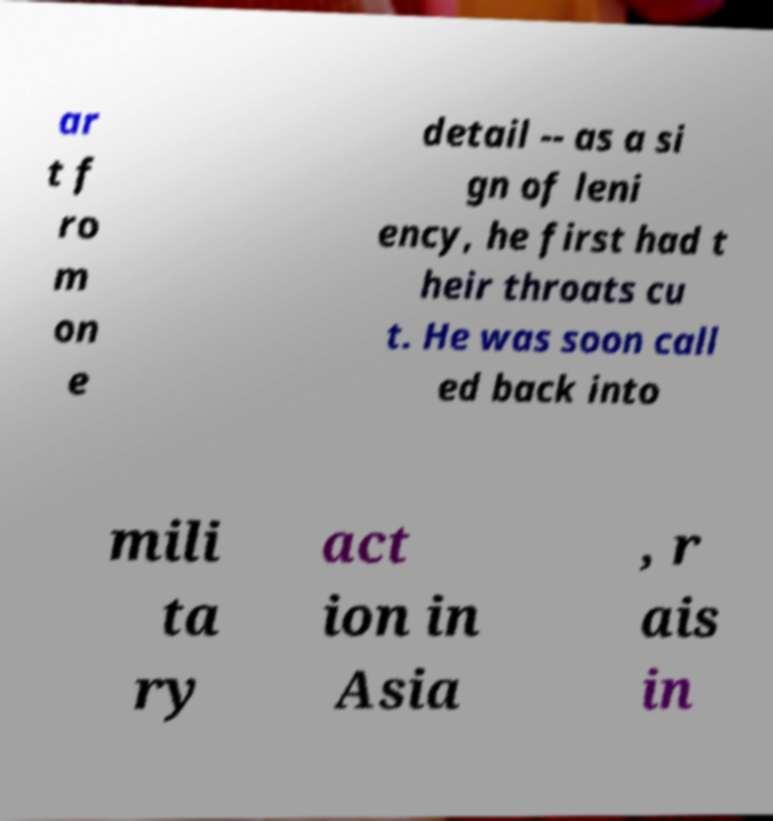Can you accurately transcribe the text from the provided image for me? ar t f ro m on e detail -- as a si gn of leni ency, he first had t heir throats cu t. He was soon call ed back into mili ta ry act ion in Asia , r ais in 